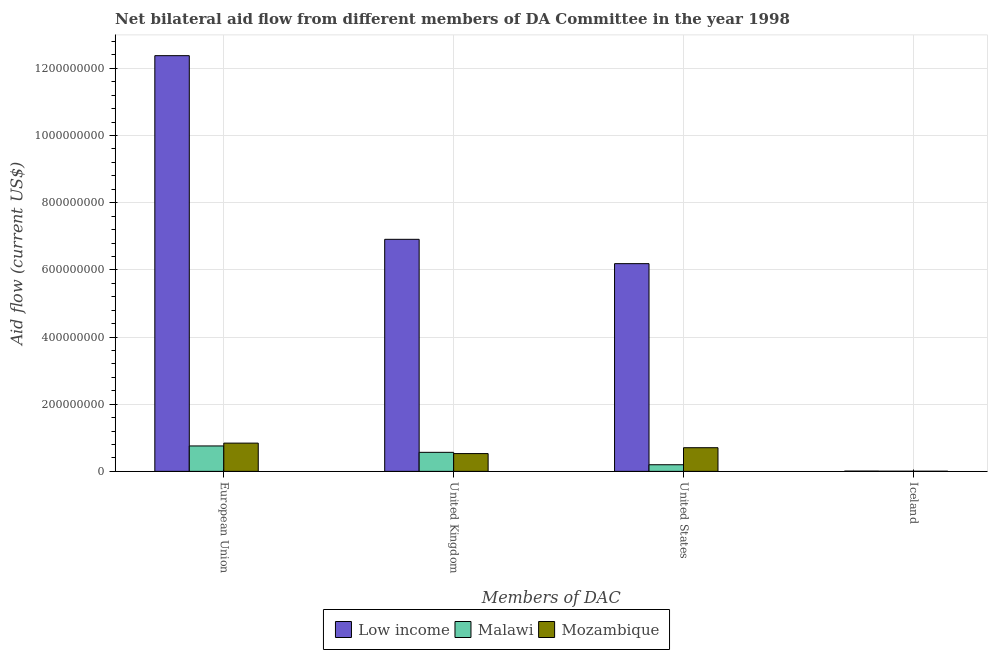Are the number of bars per tick equal to the number of legend labels?
Make the answer very short. Yes. Are the number of bars on each tick of the X-axis equal?
Provide a short and direct response. Yes. How many bars are there on the 2nd tick from the right?
Your response must be concise. 3. What is the label of the 2nd group of bars from the left?
Your answer should be compact. United Kingdom. What is the amount of aid given by iceland in Mozambique?
Give a very brief answer. 3.90e+05. Across all countries, what is the maximum amount of aid given by uk?
Offer a terse response. 6.91e+08. Across all countries, what is the minimum amount of aid given by eu?
Your answer should be very brief. 7.57e+07. In which country was the amount of aid given by us minimum?
Provide a succinct answer. Malawi. What is the total amount of aid given by uk in the graph?
Your answer should be compact. 8.01e+08. What is the difference between the amount of aid given by iceland in Mozambique and that in Malawi?
Make the answer very short. -5.00e+04. What is the difference between the amount of aid given by us in Malawi and the amount of aid given by uk in Mozambique?
Offer a terse response. -3.32e+07. What is the average amount of aid given by us per country?
Provide a succinct answer. 2.36e+08. What is the difference between the amount of aid given by uk and amount of aid given by iceland in Mozambique?
Keep it short and to the point. 5.26e+07. What is the ratio of the amount of aid given by iceland in Malawi to that in Mozambique?
Your response must be concise. 1.13. Is the difference between the amount of aid given by uk in Mozambique and Malawi greater than the difference between the amount of aid given by us in Mozambique and Malawi?
Your answer should be compact. No. What is the difference between the highest and the second highest amount of aid given by iceland?
Make the answer very short. 3.90e+05. What is the difference between the highest and the lowest amount of aid given by uk?
Give a very brief answer. 6.38e+08. Is the sum of the amount of aid given by iceland in Malawi and Low income greater than the maximum amount of aid given by eu across all countries?
Make the answer very short. No. Is it the case that in every country, the sum of the amount of aid given by eu and amount of aid given by iceland is greater than the sum of amount of aid given by uk and amount of aid given by us?
Offer a terse response. No. What does the 2nd bar from the left in Iceland represents?
Your response must be concise. Malawi. What does the 2nd bar from the right in European Union represents?
Offer a terse response. Malawi. How many bars are there?
Your response must be concise. 12. What is the difference between two consecutive major ticks on the Y-axis?
Offer a very short reply. 2.00e+08. Does the graph contain any zero values?
Give a very brief answer. No. Does the graph contain grids?
Provide a short and direct response. Yes. Where does the legend appear in the graph?
Your answer should be compact. Bottom center. How many legend labels are there?
Offer a very short reply. 3. How are the legend labels stacked?
Give a very brief answer. Horizontal. What is the title of the graph?
Your answer should be very brief. Net bilateral aid flow from different members of DA Committee in the year 1998. What is the label or title of the X-axis?
Offer a terse response. Members of DAC. What is the Aid flow (current US$) in Low income in European Union?
Your answer should be very brief. 1.24e+09. What is the Aid flow (current US$) in Malawi in European Union?
Your response must be concise. 7.57e+07. What is the Aid flow (current US$) in Mozambique in European Union?
Offer a terse response. 8.41e+07. What is the Aid flow (current US$) of Low income in United Kingdom?
Offer a very short reply. 6.91e+08. What is the Aid flow (current US$) in Malawi in United Kingdom?
Offer a terse response. 5.66e+07. What is the Aid flow (current US$) in Mozambique in United Kingdom?
Offer a very short reply. 5.30e+07. What is the Aid flow (current US$) in Low income in United States?
Offer a very short reply. 6.19e+08. What is the Aid flow (current US$) in Malawi in United States?
Your answer should be compact. 1.97e+07. What is the Aid flow (current US$) in Mozambique in United States?
Make the answer very short. 7.04e+07. What is the Aid flow (current US$) in Low income in Iceland?
Provide a succinct answer. 8.30e+05. Across all Members of DAC, what is the maximum Aid flow (current US$) of Low income?
Keep it short and to the point. 1.24e+09. Across all Members of DAC, what is the maximum Aid flow (current US$) of Malawi?
Provide a short and direct response. 7.57e+07. Across all Members of DAC, what is the maximum Aid flow (current US$) in Mozambique?
Your answer should be very brief. 8.41e+07. Across all Members of DAC, what is the minimum Aid flow (current US$) in Low income?
Your response must be concise. 8.30e+05. Across all Members of DAC, what is the minimum Aid flow (current US$) in Malawi?
Your response must be concise. 4.40e+05. Across all Members of DAC, what is the minimum Aid flow (current US$) of Mozambique?
Your response must be concise. 3.90e+05. What is the total Aid flow (current US$) of Low income in the graph?
Provide a succinct answer. 2.55e+09. What is the total Aid flow (current US$) in Malawi in the graph?
Make the answer very short. 1.53e+08. What is the total Aid flow (current US$) of Mozambique in the graph?
Provide a succinct answer. 2.08e+08. What is the difference between the Aid flow (current US$) in Low income in European Union and that in United Kingdom?
Offer a very short reply. 5.47e+08. What is the difference between the Aid flow (current US$) in Malawi in European Union and that in United Kingdom?
Give a very brief answer. 1.90e+07. What is the difference between the Aid flow (current US$) of Mozambique in European Union and that in United Kingdom?
Your answer should be very brief. 3.11e+07. What is the difference between the Aid flow (current US$) of Low income in European Union and that in United States?
Your response must be concise. 6.19e+08. What is the difference between the Aid flow (current US$) in Malawi in European Union and that in United States?
Keep it short and to the point. 5.60e+07. What is the difference between the Aid flow (current US$) of Mozambique in European Union and that in United States?
Give a very brief answer. 1.36e+07. What is the difference between the Aid flow (current US$) of Low income in European Union and that in Iceland?
Make the answer very short. 1.24e+09. What is the difference between the Aid flow (current US$) of Malawi in European Union and that in Iceland?
Give a very brief answer. 7.53e+07. What is the difference between the Aid flow (current US$) in Mozambique in European Union and that in Iceland?
Keep it short and to the point. 8.37e+07. What is the difference between the Aid flow (current US$) of Low income in United Kingdom and that in United States?
Give a very brief answer. 7.24e+07. What is the difference between the Aid flow (current US$) in Malawi in United Kingdom and that in United States?
Your response must be concise. 3.69e+07. What is the difference between the Aid flow (current US$) of Mozambique in United Kingdom and that in United States?
Provide a short and direct response. -1.75e+07. What is the difference between the Aid flow (current US$) in Low income in United Kingdom and that in Iceland?
Your answer should be compact. 6.90e+08. What is the difference between the Aid flow (current US$) of Malawi in United Kingdom and that in Iceland?
Ensure brevity in your answer.  5.62e+07. What is the difference between the Aid flow (current US$) of Mozambique in United Kingdom and that in Iceland?
Provide a succinct answer. 5.26e+07. What is the difference between the Aid flow (current US$) in Low income in United States and that in Iceland?
Keep it short and to the point. 6.18e+08. What is the difference between the Aid flow (current US$) of Malawi in United States and that in Iceland?
Provide a succinct answer. 1.93e+07. What is the difference between the Aid flow (current US$) in Mozambique in United States and that in Iceland?
Your answer should be very brief. 7.01e+07. What is the difference between the Aid flow (current US$) of Low income in European Union and the Aid flow (current US$) of Malawi in United Kingdom?
Keep it short and to the point. 1.18e+09. What is the difference between the Aid flow (current US$) of Low income in European Union and the Aid flow (current US$) of Mozambique in United Kingdom?
Your answer should be compact. 1.18e+09. What is the difference between the Aid flow (current US$) of Malawi in European Union and the Aid flow (current US$) of Mozambique in United Kingdom?
Give a very brief answer. 2.28e+07. What is the difference between the Aid flow (current US$) in Low income in European Union and the Aid flow (current US$) in Malawi in United States?
Offer a terse response. 1.22e+09. What is the difference between the Aid flow (current US$) in Low income in European Union and the Aid flow (current US$) in Mozambique in United States?
Give a very brief answer. 1.17e+09. What is the difference between the Aid flow (current US$) in Malawi in European Union and the Aid flow (current US$) in Mozambique in United States?
Ensure brevity in your answer.  5.25e+06. What is the difference between the Aid flow (current US$) of Low income in European Union and the Aid flow (current US$) of Malawi in Iceland?
Give a very brief answer. 1.24e+09. What is the difference between the Aid flow (current US$) of Low income in European Union and the Aid flow (current US$) of Mozambique in Iceland?
Your response must be concise. 1.24e+09. What is the difference between the Aid flow (current US$) of Malawi in European Union and the Aid flow (current US$) of Mozambique in Iceland?
Offer a very short reply. 7.53e+07. What is the difference between the Aid flow (current US$) of Low income in United Kingdom and the Aid flow (current US$) of Malawi in United States?
Offer a terse response. 6.71e+08. What is the difference between the Aid flow (current US$) in Low income in United Kingdom and the Aid flow (current US$) in Mozambique in United States?
Your response must be concise. 6.21e+08. What is the difference between the Aid flow (current US$) of Malawi in United Kingdom and the Aid flow (current US$) of Mozambique in United States?
Give a very brief answer. -1.38e+07. What is the difference between the Aid flow (current US$) of Low income in United Kingdom and the Aid flow (current US$) of Malawi in Iceland?
Keep it short and to the point. 6.91e+08. What is the difference between the Aid flow (current US$) of Low income in United Kingdom and the Aid flow (current US$) of Mozambique in Iceland?
Make the answer very short. 6.91e+08. What is the difference between the Aid flow (current US$) of Malawi in United Kingdom and the Aid flow (current US$) of Mozambique in Iceland?
Provide a short and direct response. 5.63e+07. What is the difference between the Aid flow (current US$) of Low income in United States and the Aid flow (current US$) of Malawi in Iceland?
Provide a succinct answer. 6.18e+08. What is the difference between the Aid flow (current US$) in Low income in United States and the Aid flow (current US$) in Mozambique in Iceland?
Your answer should be very brief. 6.18e+08. What is the difference between the Aid flow (current US$) of Malawi in United States and the Aid flow (current US$) of Mozambique in Iceland?
Your response must be concise. 1.93e+07. What is the average Aid flow (current US$) of Low income per Members of DAC?
Your response must be concise. 6.37e+08. What is the average Aid flow (current US$) of Malawi per Members of DAC?
Your response must be concise. 3.81e+07. What is the average Aid flow (current US$) of Mozambique per Members of DAC?
Make the answer very short. 5.20e+07. What is the difference between the Aid flow (current US$) in Low income and Aid flow (current US$) in Malawi in European Union?
Provide a short and direct response. 1.16e+09. What is the difference between the Aid flow (current US$) in Low income and Aid flow (current US$) in Mozambique in European Union?
Keep it short and to the point. 1.15e+09. What is the difference between the Aid flow (current US$) of Malawi and Aid flow (current US$) of Mozambique in European Union?
Provide a succinct answer. -8.39e+06. What is the difference between the Aid flow (current US$) in Low income and Aid flow (current US$) in Malawi in United Kingdom?
Provide a succinct answer. 6.34e+08. What is the difference between the Aid flow (current US$) of Low income and Aid flow (current US$) of Mozambique in United Kingdom?
Keep it short and to the point. 6.38e+08. What is the difference between the Aid flow (current US$) of Malawi and Aid flow (current US$) of Mozambique in United Kingdom?
Offer a terse response. 3.70e+06. What is the difference between the Aid flow (current US$) of Low income and Aid flow (current US$) of Malawi in United States?
Your answer should be compact. 5.99e+08. What is the difference between the Aid flow (current US$) of Low income and Aid flow (current US$) of Mozambique in United States?
Give a very brief answer. 5.48e+08. What is the difference between the Aid flow (current US$) of Malawi and Aid flow (current US$) of Mozambique in United States?
Provide a short and direct response. -5.07e+07. What is the difference between the Aid flow (current US$) of Low income and Aid flow (current US$) of Mozambique in Iceland?
Provide a short and direct response. 4.40e+05. What is the difference between the Aid flow (current US$) of Malawi and Aid flow (current US$) of Mozambique in Iceland?
Provide a succinct answer. 5.00e+04. What is the ratio of the Aid flow (current US$) in Low income in European Union to that in United Kingdom?
Offer a very short reply. 1.79. What is the ratio of the Aid flow (current US$) of Malawi in European Union to that in United Kingdom?
Offer a terse response. 1.34. What is the ratio of the Aid flow (current US$) of Mozambique in European Union to that in United Kingdom?
Give a very brief answer. 1.59. What is the ratio of the Aid flow (current US$) in Low income in European Union to that in United States?
Provide a succinct answer. 2. What is the ratio of the Aid flow (current US$) of Malawi in European Union to that in United States?
Keep it short and to the point. 3.84. What is the ratio of the Aid flow (current US$) in Mozambique in European Union to that in United States?
Provide a short and direct response. 1.19. What is the ratio of the Aid flow (current US$) of Low income in European Union to that in Iceland?
Offer a terse response. 1491.43. What is the ratio of the Aid flow (current US$) in Malawi in European Union to that in Iceland?
Your response must be concise. 172.05. What is the ratio of the Aid flow (current US$) in Mozambique in European Union to that in Iceland?
Provide a succinct answer. 215.62. What is the ratio of the Aid flow (current US$) of Low income in United Kingdom to that in United States?
Your response must be concise. 1.12. What is the ratio of the Aid flow (current US$) in Malawi in United Kingdom to that in United States?
Your response must be concise. 2.87. What is the ratio of the Aid flow (current US$) of Mozambique in United Kingdom to that in United States?
Offer a terse response. 0.75. What is the ratio of the Aid flow (current US$) of Low income in United Kingdom to that in Iceland?
Offer a very short reply. 832.48. What is the ratio of the Aid flow (current US$) in Malawi in United Kingdom to that in Iceland?
Give a very brief answer. 128.75. What is the ratio of the Aid flow (current US$) in Mozambique in United Kingdom to that in Iceland?
Keep it short and to the point. 135.77. What is the ratio of the Aid flow (current US$) in Low income in United States to that in Iceland?
Offer a terse response. 745.25. What is the ratio of the Aid flow (current US$) in Malawi in United States to that in Iceland?
Offer a terse response. 44.84. What is the ratio of the Aid flow (current US$) in Mozambique in United States to that in Iceland?
Provide a short and direct response. 180.64. What is the difference between the highest and the second highest Aid flow (current US$) in Low income?
Offer a very short reply. 5.47e+08. What is the difference between the highest and the second highest Aid flow (current US$) in Malawi?
Make the answer very short. 1.90e+07. What is the difference between the highest and the second highest Aid flow (current US$) of Mozambique?
Ensure brevity in your answer.  1.36e+07. What is the difference between the highest and the lowest Aid flow (current US$) of Low income?
Provide a short and direct response. 1.24e+09. What is the difference between the highest and the lowest Aid flow (current US$) in Malawi?
Offer a terse response. 7.53e+07. What is the difference between the highest and the lowest Aid flow (current US$) in Mozambique?
Keep it short and to the point. 8.37e+07. 